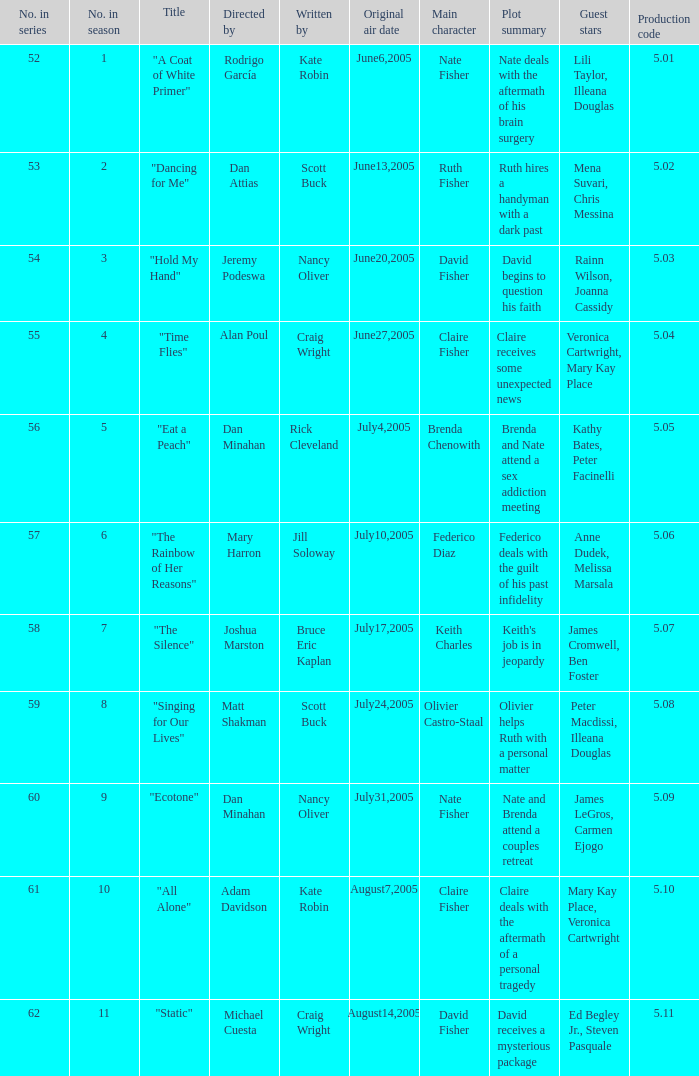What s the episode number in the season that was written by Nancy Oliver? 9.0. 